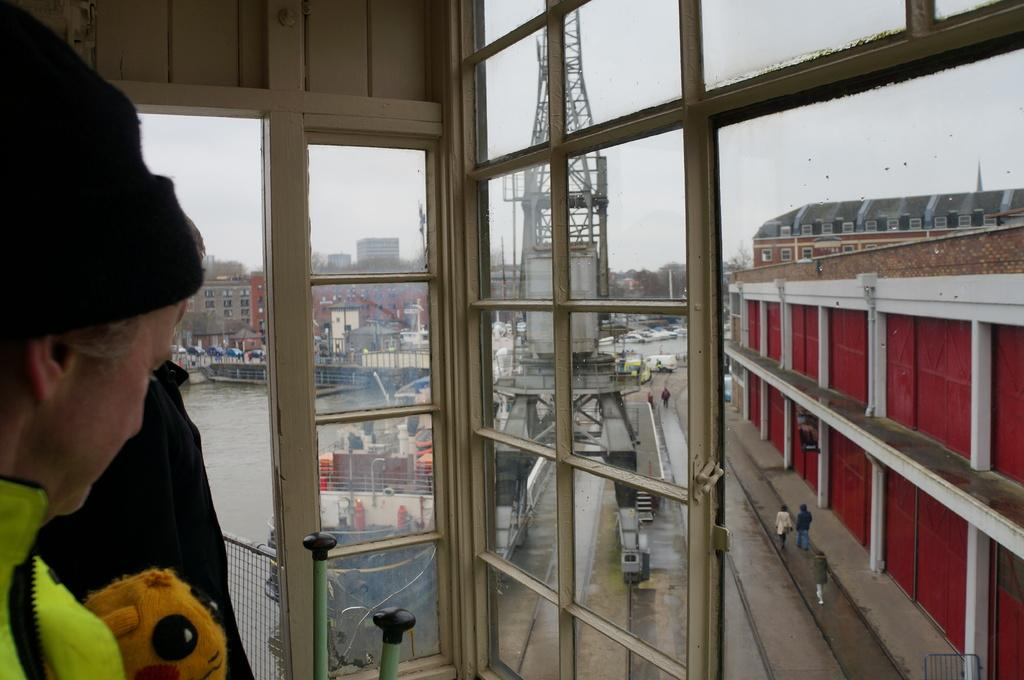What is the person in the image doing? The person in the image is operating a tower crane. What can be seen behind the crane? There are buildings in front of the crane. What natural element is visible in the image? There is water visible in the image. What type of knee surgery is the person in the image undergoing? The person in the image is operating a tower crane, not undergoing knee surgery. Can you see any fish in the water in the image? There is no mention of fish in the image, only water is visible. 